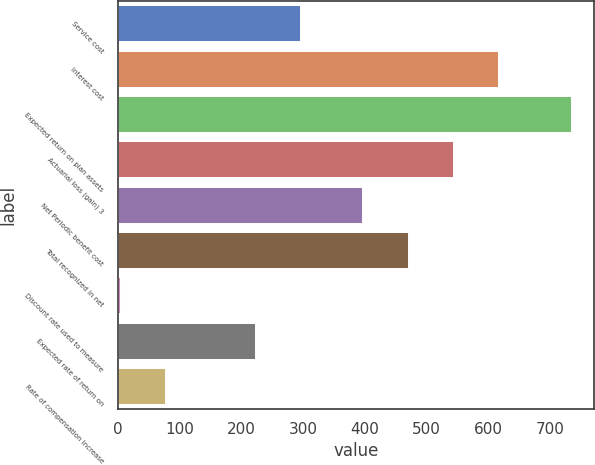Convert chart to OTSL. <chart><loc_0><loc_0><loc_500><loc_500><bar_chart><fcel>Service cost<fcel>Interest cost<fcel>Expected return on plan assets<fcel>Actuarial loss (gain) 3<fcel>Net Periodic benefit cost<fcel>Total recognized in net<fcel>Discount rate used to measure<fcel>Expected rate of return on<fcel>Rate of compensation increase<nl><fcel>295.58<fcel>615.21<fcel>734<fcel>542.14<fcel>396<fcel>469.07<fcel>3.3<fcel>222.51<fcel>76.37<nl></chart> 